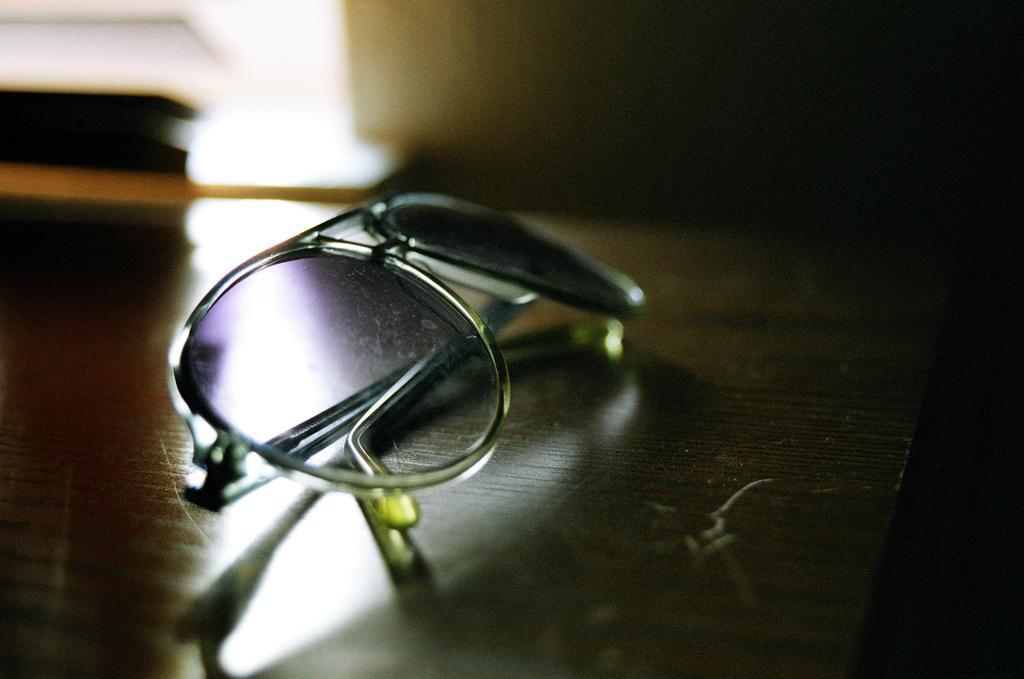How would you summarize this image in a sentence or two? In this image, I can see the goggles placed on the wooden table. The background looks blurry. 